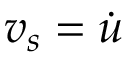Convert formula to latex. <formula><loc_0><loc_0><loc_500><loc_500>v _ { s } = \dot { u }</formula> 